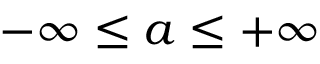Convert formula to latex. <formula><loc_0><loc_0><loc_500><loc_500>- \infty \leq a \leq + \infty</formula> 